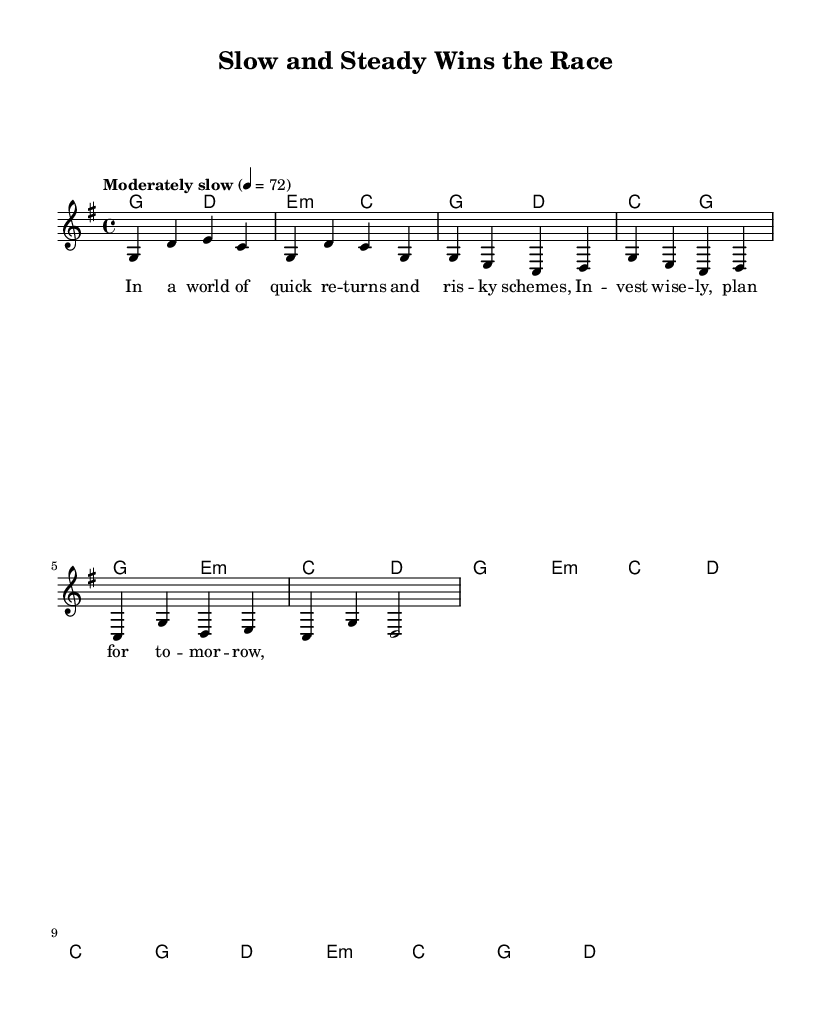What is the key signature of this music? The key signature is G major, which has one sharp (F#). We can identify the key signature by looking at the beginning of the staff where it shows a single sharp on the F line.
Answer: G major What is the time signature of this music? The time signature is 4/4, which means there are four beats in each measure and a quarter note gets one beat. This is indicated at the beginning of the score next to the clef.
Answer: 4/4 What is the tempo marking for this piece? The tempo marking indicates a moderately slow pace at a rate of 72 beats per minute, as noted in the tempo text at the start of the score that states "Moderately slow" followed by the value.
Answer: 72 How many measures are in the verse section provided? The verse section has four measures, which can be counted from the melody and chord sections specifically noted for Verse 1. Each grouping in the musical staff represents one measure.
Answer: 4 What is the overall theme of this song? The overall theme revolves around financial wisdom and long-term planning, as reflected in the lyrics that emphasize avoiding risky schemes and planning for the future. This theme is directly related to the context of the lyrics and titles provided in the score.
Answer: Financial responsibility What is the last chord in the last measure of the chorus? The last chord in the last measure of the chorus is a D major chord. This can be confirmed by examining the chord symbols listed above the melody in the corresponding section in the score.
Answer: D 